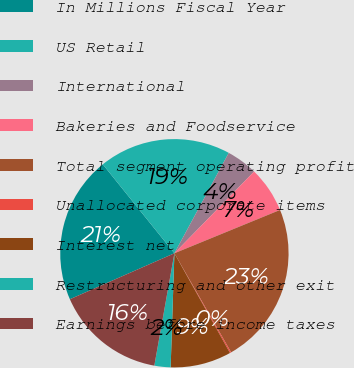Convert chart. <chart><loc_0><loc_0><loc_500><loc_500><pie_chart><fcel>In Millions Fiscal Year<fcel>US Retail<fcel>International<fcel>Bakeries and Foodservice<fcel>Total segment operating profit<fcel>Unallocated corporate items<fcel>Interest net<fcel>Restructuring and other exit<fcel>Earnings before income taxes<nl><fcel>20.81%<fcel>18.69%<fcel>4.4%<fcel>6.51%<fcel>22.92%<fcel>0.18%<fcel>8.62%<fcel>2.29%<fcel>15.59%<nl></chart> 